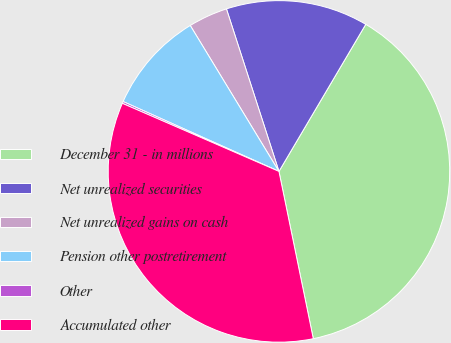<chart> <loc_0><loc_0><loc_500><loc_500><pie_chart><fcel>December 31 - in millions<fcel>Net unrealized securities<fcel>Net unrealized gains on cash<fcel>Pension other postretirement<fcel>Other<fcel>Accumulated other<nl><fcel>38.29%<fcel>13.46%<fcel>3.72%<fcel>9.6%<fcel>0.18%<fcel>34.75%<nl></chart> 